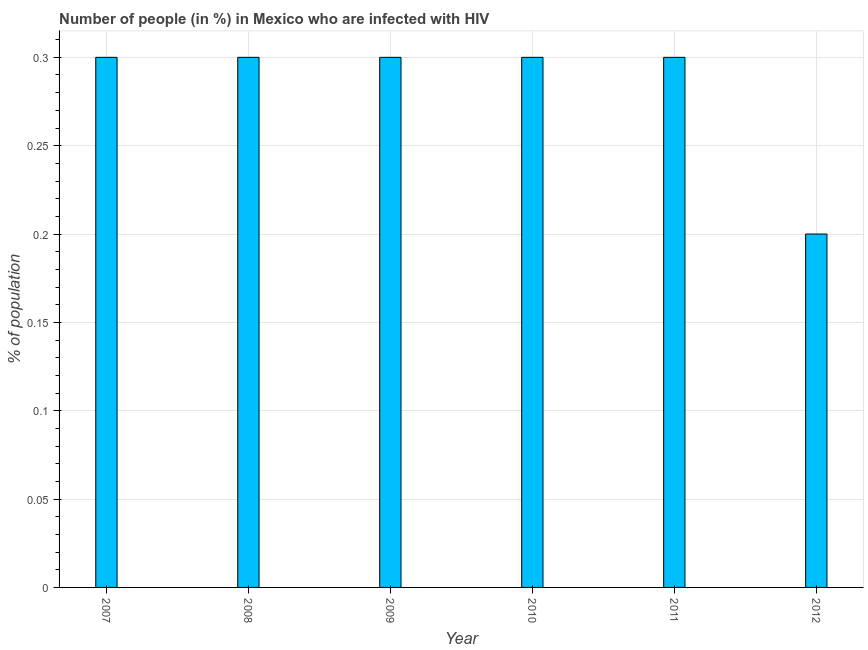Does the graph contain any zero values?
Your response must be concise. No. Does the graph contain grids?
Provide a succinct answer. Yes. What is the title of the graph?
Offer a very short reply. Number of people (in %) in Mexico who are infected with HIV. What is the label or title of the X-axis?
Your answer should be very brief. Year. What is the label or title of the Y-axis?
Provide a short and direct response. % of population. Across all years, what is the minimum number of people infected with hiv?
Offer a very short reply. 0.2. In which year was the number of people infected with hiv maximum?
Offer a terse response. 2007. In which year was the number of people infected with hiv minimum?
Make the answer very short. 2012. What is the sum of the number of people infected with hiv?
Offer a terse response. 1.7. What is the difference between the number of people infected with hiv in 2008 and 2012?
Give a very brief answer. 0.1. What is the average number of people infected with hiv per year?
Ensure brevity in your answer.  0.28. In how many years, is the number of people infected with hiv greater than 0.25 %?
Your response must be concise. 5. Is the sum of the number of people infected with hiv in 2011 and 2012 greater than the maximum number of people infected with hiv across all years?
Make the answer very short. Yes. What is the difference between the highest and the lowest number of people infected with hiv?
Make the answer very short. 0.1. In how many years, is the number of people infected with hiv greater than the average number of people infected with hiv taken over all years?
Provide a short and direct response. 5. How many years are there in the graph?
Ensure brevity in your answer.  6. What is the % of population of 2008?
Offer a terse response. 0.3. What is the % of population in 2009?
Ensure brevity in your answer.  0.3. What is the difference between the % of population in 2007 and 2008?
Give a very brief answer. 0. What is the difference between the % of population in 2007 and 2010?
Provide a succinct answer. 0. What is the difference between the % of population in 2007 and 2011?
Keep it short and to the point. 0. What is the difference between the % of population in 2008 and 2010?
Your answer should be compact. 0. What is the difference between the % of population in 2008 and 2011?
Ensure brevity in your answer.  0. What is the difference between the % of population in 2008 and 2012?
Your answer should be compact. 0.1. What is the difference between the % of population in 2009 and 2011?
Offer a terse response. 0. What is the difference between the % of population in 2009 and 2012?
Your answer should be very brief. 0.1. What is the difference between the % of population in 2010 and 2011?
Your answer should be compact. 0. What is the difference between the % of population in 2010 and 2012?
Give a very brief answer. 0.1. What is the ratio of the % of population in 2007 to that in 2008?
Provide a succinct answer. 1. What is the ratio of the % of population in 2007 to that in 2009?
Give a very brief answer. 1. What is the ratio of the % of population in 2008 to that in 2010?
Provide a succinct answer. 1. What is the ratio of the % of population in 2008 to that in 2012?
Your answer should be very brief. 1.5. What is the ratio of the % of population in 2009 to that in 2011?
Provide a succinct answer. 1. What is the ratio of the % of population in 2009 to that in 2012?
Your response must be concise. 1.5. What is the ratio of the % of population in 2011 to that in 2012?
Your response must be concise. 1.5. 